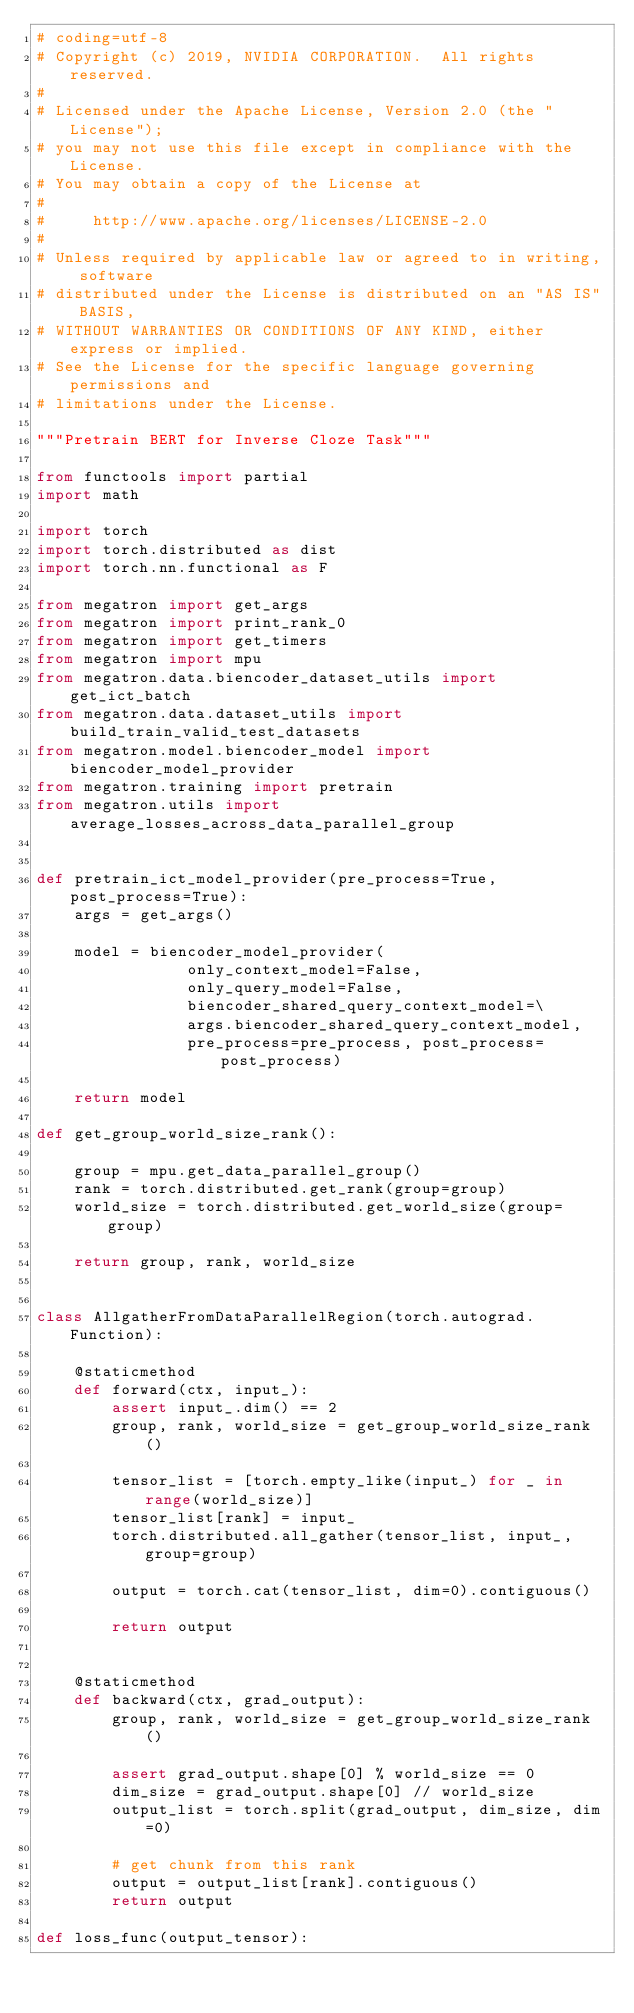<code> <loc_0><loc_0><loc_500><loc_500><_Python_># coding=utf-8
# Copyright (c) 2019, NVIDIA CORPORATION.  All rights reserved.
#
# Licensed under the Apache License, Version 2.0 (the "License");
# you may not use this file except in compliance with the License.
# You may obtain a copy of the License at
#
#     http://www.apache.org/licenses/LICENSE-2.0
#
# Unless required by applicable law or agreed to in writing, software
# distributed under the License is distributed on an "AS IS" BASIS,
# WITHOUT WARRANTIES OR CONDITIONS OF ANY KIND, either express or implied.
# See the License for the specific language governing permissions and
# limitations under the License.

"""Pretrain BERT for Inverse Cloze Task"""

from functools import partial
import math

import torch
import torch.distributed as dist
import torch.nn.functional as F

from megatron import get_args
from megatron import print_rank_0
from megatron import get_timers
from megatron import mpu
from megatron.data.biencoder_dataset_utils import get_ict_batch
from megatron.data.dataset_utils import build_train_valid_test_datasets
from megatron.model.biencoder_model import biencoder_model_provider
from megatron.training import pretrain
from megatron.utils import average_losses_across_data_parallel_group


def pretrain_ict_model_provider(pre_process=True, post_process=True):
    args = get_args()

    model = biencoder_model_provider(
                only_context_model=False,
                only_query_model=False,
                biencoder_shared_query_context_model=\
                args.biencoder_shared_query_context_model,
                pre_process=pre_process, post_process=post_process)

    return model

def get_group_world_size_rank():

    group = mpu.get_data_parallel_group()
    rank = torch.distributed.get_rank(group=group)
    world_size = torch.distributed.get_world_size(group=group)

    return group, rank, world_size


class AllgatherFromDataParallelRegion(torch.autograd.Function):

    @staticmethod
    def forward(ctx, input_):
        assert input_.dim() == 2
        group, rank, world_size = get_group_world_size_rank()

        tensor_list = [torch.empty_like(input_) for _ in range(world_size)]
        tensor_list[rank] = input_
        torch.distributed.all_gather(tensor_list, input_, group=group)

        output = torch.cat(tensor_list, dim=0).contiguous()

        return output


    @staticmethod
    def backward(ctx, grad_output):
        group, rank, world_size = get_group_world_size_rank()

        assert grad_output.shape[0] % world_size == 0
        dim_size = grad_output.shape[0] // world_size
        output_list = torch.split(grad_output, dim_size, dim=0)

        # get chunk from this rank
        output = output_list[rank].contiguous()
        return output

def loss_func(output_tensor):</code> 